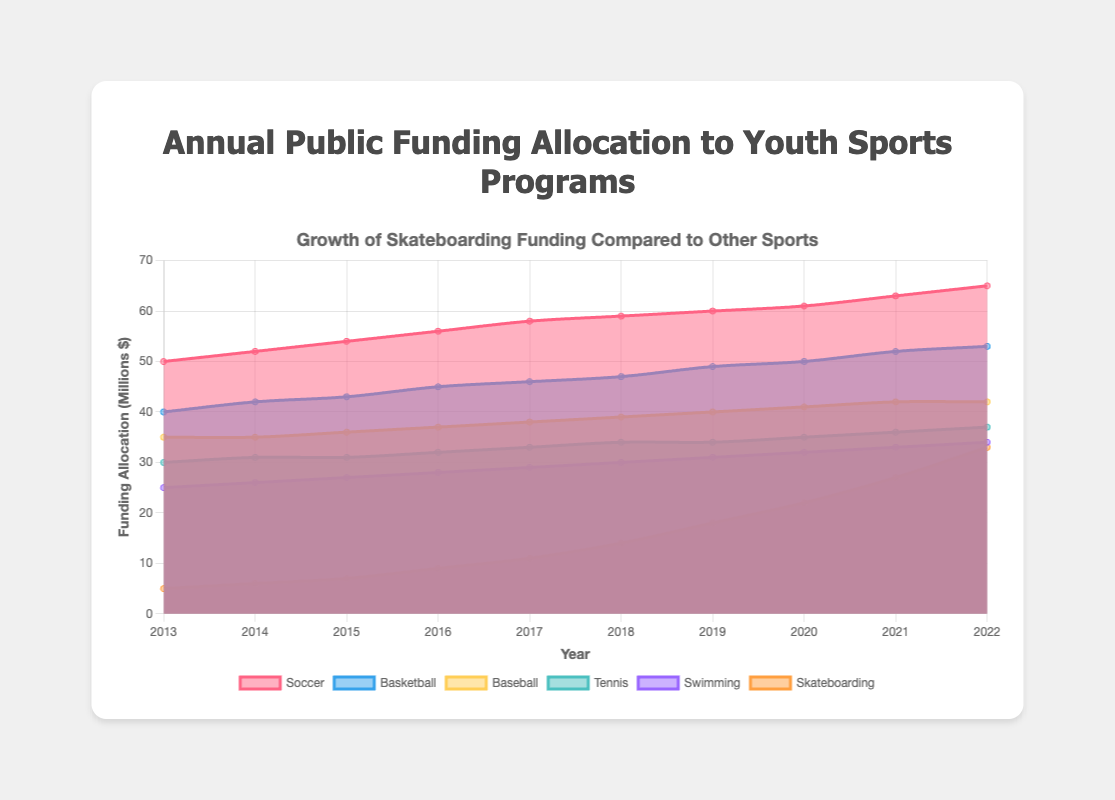What's the title of the chart? The title is displayed at the top of the chart, and it reads "Growth of Skateboarding Funding Compared to Other Sports."
Answer: Growth of Skateboarding Funding Compared to Other Sports Which sport received the highest funding allocation in 2022? The dataset indicates the funding evolution for each sport, and in 2022, Soccer has the highest value.
Answer: Soccer How has funding for skateboarding changed from 2013 to 2022? Starting at 5 million dollars in 2013, funding for skateboarding steadily increased to 33 million dollars by 2022.
Answer: Increased from 5 million to 33 million dollars Compare the funding between swimming and skateboarding programs in 2022. In 2022, funding for swimming is represented by a value of 34 million dollars whereas skateboarding shows 33 million dollars.
Answer: Swimming received 34 million dollars, Skateboarding received 33 million dollars What is the average annual increase in funding for skateboarding programs from 2013 to 2022? Calculate the total increase in funding (33 million in 2022 - 5 million in 2013 = 28 million) and divide by the number of years (10).
Answer: 2.8 million dollars per year Between which two consecutive years did skateboarding funding see the highest increase? Examining the differences year-on-year, the highest increase was from 2017 to 2018 with a jump from 11 to 14 million dollars.
Answer: 2017-2018 How does funding for basketball compare to soccer in 2022? In 2022, basketball funding stands at 53 million dollars compared to soccer’s 65 million dollars.
Answer: Soccer received 12 million dollars more than basketball What trend can you observe for the overall funding allocations to youth sports programs in the chart? All sports show an increasing trend in funding allocations over the decade, indicating a growing investment in youth sports programs.
Answer: Increasing trend How did the funding allocation for tennis change over the past decade? Tennis funding went from 30 million dollars in 2013 to 37 million dollars in 2022, showing a steady increase each year.
Answer: Increased by 7 million dollars What proportion of the soccer funding in 2022 does skateboarding funding represent in the same year? Skateboarding funding in 2022 is 33 million dollars, and soccer funding is 65 million dollars. The proportion is 33/65, approximately 0.51.
Answer: Around 51% 